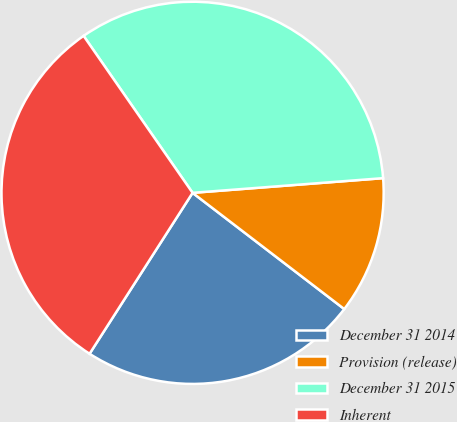Convert chart to OTSL. <chart><loc_0><loc_0><loc_500><loc_500><pie_chart><fcel>December 31 2014<fcel>Provision (release)<fcel>December 31 2015<fcel>Inherent<nl><fcel>23.66%<fcel>11.63%<fcel>33.44%<fcel>31.28%<nl></chart> 